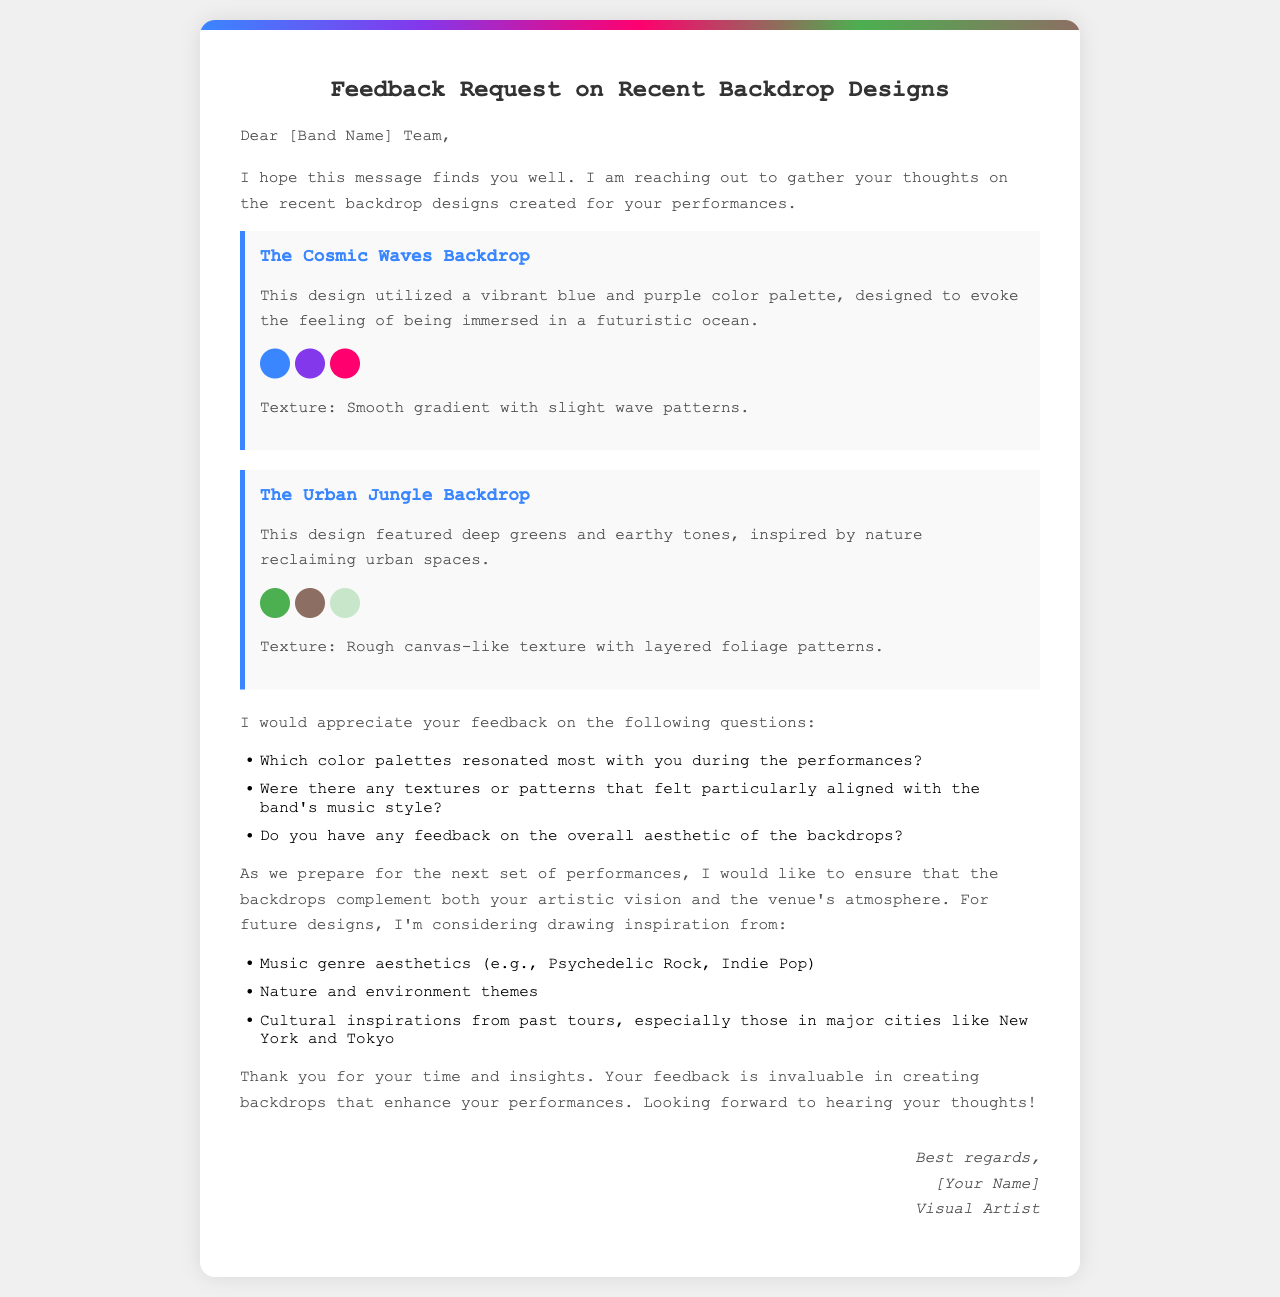What is the title of the document? The title of the document is presented at the top and indicates the purpose, which is to request feedback on backdrop designs.
Answer: Feedback Request on Recent Backdrop Designs How many backdrop designs are detailed in the document? There are two different backdrop designs described in the document.
Answer: Two What color is primarily used in the Cosmic Waves Backdrop? The Cosmic Waves Backdrop features a vibrant blue color as one of its main elements.
Answer: Blue Which texture is associated with the Urban Jungle Backdrop? The document describes the texture of the Urban Jungle Backdrop as having a rough canvas-like quality.
Answer: Rough canvas-like texture What specific feedback is requested regarding color palettes? The request includes feedback on which color palettes resonated most with the band during performances.
Answer: Color palettes resonated What themes are suggested for future backdrop designs? The document mentions that inspirations for future designs could be drawn from various themes including nature and music genres.
Answer: Nature and music genre Who is the author of the letter? The signature at the bottom of the letter identifies the author as a visual artist.
Answer: [Your Name] What is the purpose of the letter? The primary intention of the letter is to gather feedback from the band regarding backdrop designs.
Answer: Gather feedback on backdrop designs 